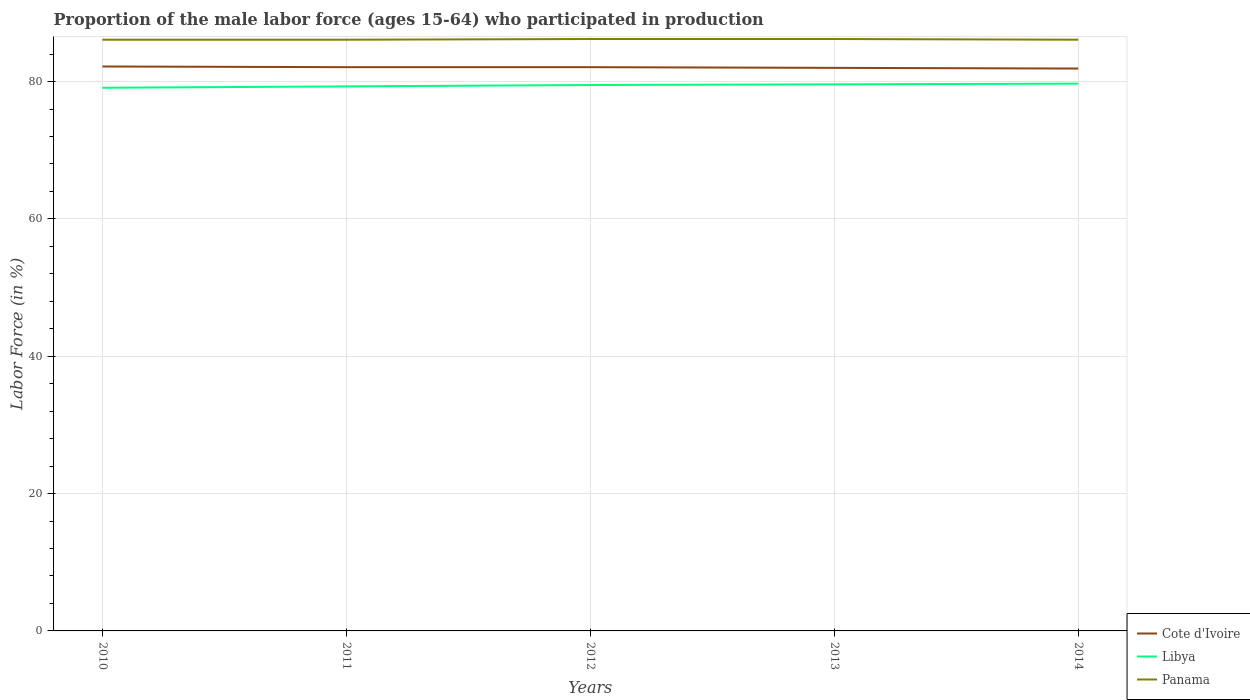How many different coloured lines are there?
Ensure brevity in your answer.  3. Across all years, what is the maximum proportion of the male labor force who participated in production in Cote d'Ivoire?
Offer a very short reply. 81.9. In which year was the proportion of the male labor force who participated in production in Panama maximum?
Make the answer very short. 2010. What is the total proportion of the male labor force who participated in production in Libya in the graph?
Provide a succinct answer. -0.2. What is the difference between the highest and the second highest proportion of the male labor force who participated in production in Cote d'Ivoire?
Offer a very short reply. 0.3. How many lines are there?
Your answer should be compact. 3. What is the difference between two consecutive major ticks on the Y-axis?
Make the answer very short. 20. Are the values on the major ticks of Y-axis written in scientific E-notation?
Give a very brief answer. No. Does the graph contain grids?
Provide a short and direct response. Yes. How are the legend labels stacked?
Offer a very short reply. Vertical. What is the title of the graph?
Provide a short and direct response. Proportion of the male labor force (ages 15-64) who participated in production. Does "Middle East & North Africa (developing only)" appear as one of the legend labels in the graph?
Make the answer very short. No. What is the label or title of the X-axis?
Ensure brevity in your answer.  Years. What is the label or title of the Y-axis?
Keep it short and to the point. Labor Force (in %). What is the Labor Force (in %) in Cote d'Ivoire in 2010?
Your response must be concise. 82.2. What is the Labor Force (in %) in Libya in 2010?
Keep it short and to the point. 79.1. What is the Labor Force (in %) in Panama in 2010?
Your response must be concise. 86.1. What is the Labor Force (in %) of Cote d'Ivoire in 2011?
Keep it short and to the point. 82.1. What is the Labor Force (in %) of Libya in 2011?
Your answer should be very brief. 79.3. What is the Labor Force (in %) of Panama in 2011?
Offer a very short reply. 86.1. What is the Labor Force (in %) in Cote d'Ivoire in 2012?
Offer a terse response. 82.1. What is the Labor Force (in %) in Libya in 2012?
Provide a short and direct response. 79.5. What is the Labor Force (in %) of Panama in 2012?
Provide a short and direct response. 86.2. What is the Labor Force (in %) in Cote d'Ivoire in 2013?
Your answer should be very brief. 82. What is the Labor Force (in %) of Libya in 2013?
Give a very brief answer. 79.6. What is the Labor Force (in %) of Panama in 2013?
Provide a succinct answer. 86.2. What is the Labor Force (in %) in Cote d'Ivoire in 2014?
Provide a succinct answer. 81.9. What is the Labor Force (in %) in Libya in 2014?
Provide a succinct answer. 79.7. What is the Labor Force (in %) of Panama in 2014?
Offer a terse response. 86.1. Across all years, what is the maximum Labor Force (in %) in Cote d'Ivoire?
Your answer should be very brief. 82.2. Across all years, what is the maximum Labor Force (in %) of Libya?
Your response must be concise. 79.7. Across all years, what is the maximum Labor Force (in %) in Panama?
Ensure brevity in your answer.  86.2. Across all years, what is the minimum Labor Force (in %) in Cote d'Ivoire?
Provide a succinct answer. 81.9. Across all years, what is the minimum Labor Force (in %) of Libya?
Provide a succinct answer. 79.1. Across all years, what is the minimum Labor Force (in %) of Panama?
Your response must be concise. 86.1. What is the total Labor Force (in %) of Cote d'Ivoire in the graph?
Ensure brevity in your answer.  410.3. What is the total Labor Force (in %) of Libya in the graph?
Provide a short and direct response. 397.2. What is the total Labor Force (in %) in Panama in the graph?
Your answer should be very brief. 430.7. What is the difference between the Labor Force (in %) of Cote d'Ivoire in 2010 and that in 2011?
Provide a short and direct response. 0.1. What is the difference between the Labor Force (in %) of Libya in 2010 and that in 2012?
Offer a very short reply. -0.4. What is the difference between the Labor Force (in %) in Panama in 2010 and that in 2012?
Make the answer very short. -0.1. What is the difference between the Labor Force (in %) in Cote d'Ivoire in 2010 and that in 2013?
Make the answer very short. 0.2. What is the difference between the Labor Force (in %) of Cote d'Ivoire in 2010 and that in 2014?
Provide a short and direct response. 0.3. What is the difference between the Labor Force (in %) in Libya in 2010 and that in 2014?
Provide a short and direct response. -0.6. What is the difference between the Labor Force (in %) of Panama in 2010 and that in 2014?
Your answer should be very brief. 0. What is the difference between the Labor Force (in %) in Cote d'Ivoire in 2011 and that in 2012?
Your answer should be compact. 0. What is the difference between the Labor Force (in %) of Libya in 2011 and that in 2012?
Ensure brevity in your answer.  -0.2. What is the difference between the Labor Force (in %) in Panama in 2011 and that in 2012?
Your response must be concise. -0.1. What is the difference between the Labor Force (in %) in Cote d'Ivoire in 2011 and that in 2013?
Your response must be concise. 0.1. What is the difference between the Labor Force (in %) of Panama in 2011 and that in 2013?
Your answer should be very brief. -0.1. What is the difference between the Labor Force (in %) in Libya in 2011 and that in 2014?
Give a very brief answer. -0.4. What is the difference between the Labor Force (in %) in Panama in 2011 and that in 2014?
Ensure brevity in your answer.  0. What is the difference between the Labor Force (in %) in Panama in 2012 and that in 2014?
Give a very brief answer. 0.1. What is the difference between the Labor Force (in %) of Libya in 2013 and that in 2014?
Offer a very short reply. -0.1. What is the difference between the Labor Force (in %) in Cote d'Ivoire in 2010 and the Labor Force (in %) in Libya in 2011?
Your response must be concise. 2.9. What is the difference between the Labor Force (in %) of Cote d'Ivoire in 2010 and the Labor Force (in %) of Panama in 2011?
Your answer should be compact. -3.9. What is the difference between the Labor Force (in %) of Cote d'Ivoire in 2010 and the Labor Force (in %) of Panama in 2012?
Your answer should be compact. -4. What is the difference between the Labor Force (in %) of Libya in 2010 and the Labor Force (in %) of Panama in 2012?
Provide a succinct answer. -7.1. What is the difference between the Labor Force (in %) in Cote d'Ivoire in 2010 and the Labor Force (in %) in Libya in 2013?
Provide a succinct answer. 2.6. What is the difference between the Labor Force (in %) of Cote d'Ivoire in 2010 and the Labor Force (in %) of Panama in 2013?
Provide a short and direct response. -4. What is the difference between the Labor Force (in %) of Cote d'Ivoire in 2010 and the Labor Force (in %) of Panama in 2014?
Ensure brevity in your answer.  -3.9. What is the difference between the Labor Force (in %) of Libya in 2010 and the Labor Force (in %) of Panama in 2014?
Offer a very short reply. -7. What is the difference between the Labor Force (in %) of Cote d'Ivoire in 2011 and the Labor Force (in %) of Libya in 2012?
Offer a terse response. 2.6. What is the difference between the Labor Force (in %) of Cote d'Ivoire in 2011 and the Labor Force (in %) of Panama in 2012?
Your answer should be compact. -4.1. What is the difference between the Labor Force (in %) of Libya in 2011 and the Labor Force (in %) of Panama in 2012?
Provide a short and direct response. -6.9. What is the difference between the Labor Force (in %) of Cote d'Ivoire in 2011 and the Labor Force (in %) of Libya in 2013?
Ensure brevity in your answer.  2.5. What is the difference between the Labor Force (in %) of Cote d'Ivoire in 2011 and the Labor Force (in %) of Panama in 2013?
Give a very brief answer. -4.1. What is the difference between the Labor Force (in %) of Libya in 2011 and the Labor Force (in %) of Panama in 2014?
Keep it short and to the point. -6.8. What is the difference between the Labor Force (in %) in Libya in 2012 and the Labor Force (in %) in Panama in 2013?
Offer a terse response. -6.7. What is the difference between the Labor Force (in %) in Cote d'Ivoire in 2012 and the Labor Force (in %) in Libya in 2014?
Give a very brief answer. 2.4. What is the difference between the Labor Force (in %) in Cote d'Ivoire in 2012 and the Labor Force (in %) in Panama in 2014?
Your response must be concise. -4. What is the difference between the Labor Force (in %) in Cote d'Ivoire in 2013 and the Labor Force (in %) in Libya in 2014?
Offer a terse response. 2.3. What is the average Labor Force (in %) in Cote d'Ivoire per year?
Keep it short and to the point. 82.06. What is the average Labor Force (in %) of Libya per year?
Offer a terse response. 79.44. What is the average Labor Force (in %) in Panama per year?
Offer a very short reply. 86.14. In the year 2010, what is the difference between the Labor Force (in %) of Cote d'Ivoire and Labor Force (in %) of Panama?
Your answer should be compact. -3.9. In the year 2011, what is the difference between the Labor Force (in %) of Cote d'Ivoire and Labor Force (in %) of Libya?
Your response must be concise. 2.8. In the year 2011, what is the difference between the Labor Force (in %) of Cote d'Ivoire and Labor Force (in %) of Panama?
Offer a terse response. -4. In the year 2011, what is the difference between the Labor Force (in %) of Libya and Labor Force (in %) of Panama?
Your answer should be very brief. -6.8. In the year 2014, what is the difference between the Labor Force (in %) of Cote d'Ivoire and Labor Force (in %) of Libya?
Your response must be concise. 2.2. In the year 2014, what is the difference between the Labor Force (in %) of Libya and Labor Force (in %) of Panama?
Give a very brief answer. -6.4. What is the ratio of the Labor Force (in %) in Cote d'Ivoire in 2010 to that in 2012?
Provide a succinct answer. 1. What is the ratio of the Labor Force (in %) of Cote d'Ivoire in 2010 to that in 2013?
Your response must be concise. 1. What is the ratio of the Labor Force (in %) of Panama in 2010 to that in 2013?
Keep it short and to the point. 1. What is the ratio of the Labor Force (in %) in Libya in 2010 to that in 2014?
Provide a succinct answer. 0.99. What is the ratio of the Labor Force (in %) of Panama in 2010 to that in 2014?
Your response must be concise. 1. What is the ratio of the Labor Force (in %) in Cote d'Ivoire in 2011 to that in 2012?
Offer a terse response. 1. What is the ratio of the Labor Force (in %) of Libya in 2011 to that in 2012?
Make the answer very short. 1. What is the ratio of the Labor Force (in %) in Cote d'Ivoire in 2012 to that in 2013?
Give a very brief answer. 1. What is the ratio of the Labor Force (in %) of Cote d'Ivoire in 2012 to that in 2014?
Keep it short and to the point. 1. What is the ratio of the Labor Force (in %) of Libya in 2012 to that in 2014?
Provide a short and direct response. 1. What is the ratio of the Labor Force (in %) in Panama in 2013 to that in 2014?
Offer a terse response. 1. What is the difference between the highest and the second highest Labor Force (in %) of Libya?
Offer a very short reply. 0.1. What is the difference between the highest and the second highest Labor Force (in %) in Panama?
Provide a short and direct response. 0. What is the difference between the highest and the lowest Labor Force (in %) in Libya?
Provide a succinct answer. 0.6. What is the difference between the highest and the lowest Labor Force (in %) of Panama?
Your answer should be very brief. 0.1. 